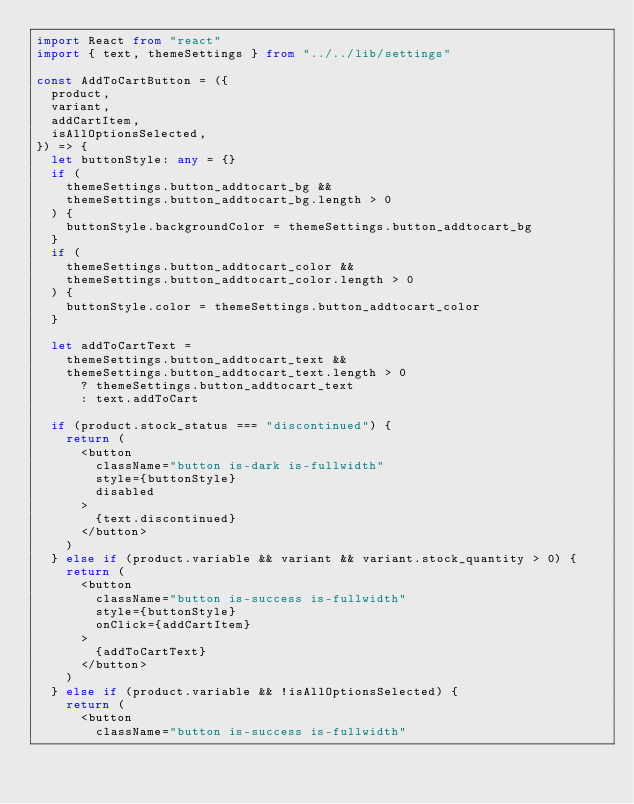<code> <loc_0><loc_0><loc_500><loc_500><_TypeScript_>import React from "react"
import { text, themeSettings } from "../../lib/settings"

const AddToCartButton = ({
  product,
  variant,
  addCartItem,
  isAllOptionsSelected,
}) => {
  let buttonStyle: any = {}
  if (
    themeSettings.button_addtocart_bg &&
    themeSettings.button_addtocart_bg.length > 0
  ) {
    buttonStyle.backgroundColor = themeSettings.button_addtocart_bg
  }
  if (
    themeSettings.button_addtocart_color &&
    themeSettings.button_addtocart_color.length > 0
  ) {
    buttonStyle.color = themeSettings.button_addtocart_color
  }

  let addToCartText =
    themeSettings.button_addtocart_text &&
    themeSettings.button_addtocart_text.length > 0
      ? themeSettings.button_addtocart_text
      : text.addToCart

  if (product.stock_status === "discontinued") {
    return (
      <button
        className="button is-dark is-fullwidth"
        style={buttonStyle}
        disabled
      >
        {text.discontinued}
      </button>
    )
  } else if (product.variable && variant && variant.stock_quantity > 0) {
    return (
      <button
        className="button is-success is-fullwidth"
        style={buttonStyle}
        onClick={addCartItem}
      >
        {addToCartText}
      </button>
    )
  } else if (product.variable && !isAllOptionsSelected) {
    return (
      <button
        className="button is-success is-fullwidth"</code> 